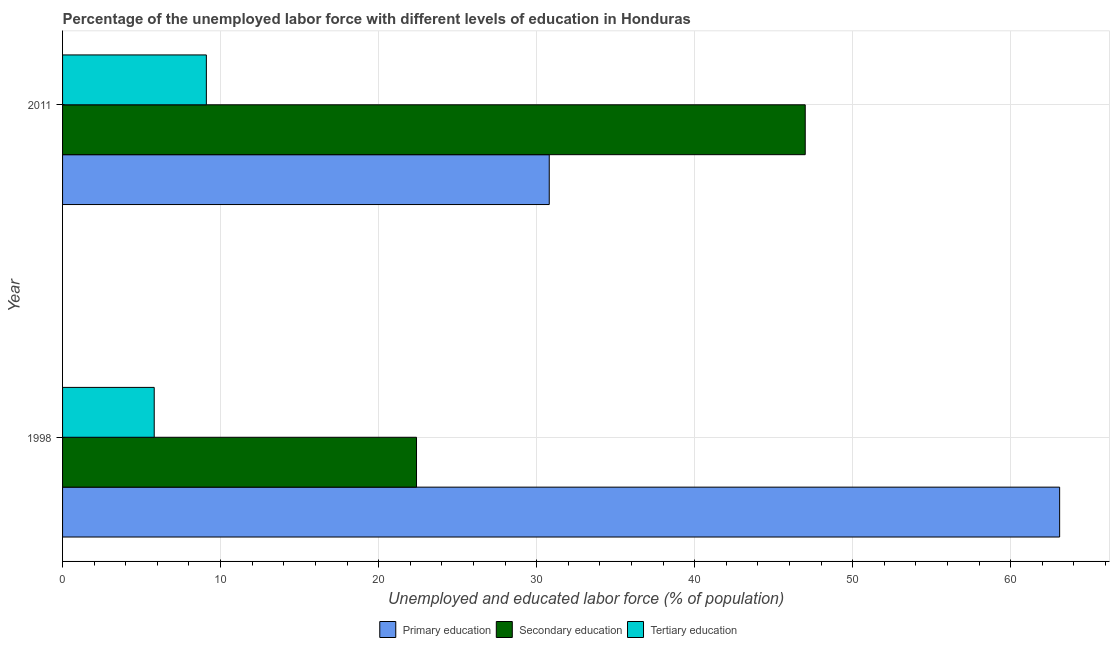How many different coloured bars are there?
Keep it short and to the point. 3. Are the number of bars on each tick of the Y-axis equal?
Make the answer very short. Yes. How many bars are there on the 1st tick from the bottom?
Your answer should be compact. 3. What is the label of the 2nd group of bars from the top?
Your answer should be very brief. 1998. What is the percentage of labor force who received tertiary education in 1998?
Your answer should be compact. 5.8. Across all years, what is the maximum percentage of labor force who received primary education?
Your answer should be very brief. 63.1. Across all years, what is the minimum percentage of labor force who received secondary education?
Your response must be concise. 22.4. What is the total percentage of labor force who received tertiary education in the graph?
Provide a short and direct response. 14.9. What is the difference between the percentage of labor force who received primary education in 1998 and that in 2011?
Ensure brevity in your answer.  32.3. What is the difference between the percentage of labor force who received tertiary education in 2011 and the percentage of labor force who received primary education in 1998?
Provide a succinct answer. -54. What is the average percentage of labor force who received secondary education per year?
Make the answer very short. 34.7. In the year 1998, what is the difference between the percentage of labor force who received secondary education and percentage of labor force who received primary education?
Provide a succinct answer. -40.7. What is the ratio of the percentage of labor force who received primary education in 1998 to that in 2011?
Make the answer very short. 2.05. What does the 2nd bar from the top in 2011 represents?
Give a very brief answer. Secondary education. What does the 3rd bar from the bottom in 2011 represents?
Your answer should be compact. Tertiary education. How many bars are there?
Make the answer very short. 6. What is the difference between two consecutive major ticks on the X-axis?
Provide a short and direct response. 10. What is the title of the graph?
Your response must be concise. Percentage of the unemployed labor force with different levels of education in Honduras. What is the label or title of the X-axis?
Give a very brief answer. Unemployed and educated labor force (% of population). What is the Unemployed and educated labor force (% of population) of Primary education in 1998?
Keep it short and to the point. 63.1. What is the Unemployed and educated labor force (% of population) of Secondary education in 1998?
Offer a terse response. 22.4. What is the Unemployed and educated labor force (% of population) in Tertiary education in 1998?
Offer a terse response. 5.8. What is the Unemployed and educated labor force (% of population) of Primary education in 2011?
Your response must be concise. 30.8. What is the Unemployed and educated labor force (% of population) in Tertiary education in 2011?
Provide a short and direct response. 9.1. Across all years, what is the maximum Unemployed and educated labor force (% of population) of Primary education?
Provide a succinct answer. 63.1. Across all years, what is the maximum Unemployed and educated labor force (% of population) in Secondary education?
Provide a succinct answer. 47. Across all years, what is the maximum Unemployed and educated labor force (% of population) in Tertiary education?
Ensure brevity in your answer.  9.1. Across all years, what is the minimum Unemployed and educated labor force (% of population) in Primary education?
Your response must be concise. 30.8. Across all years, what is the minimum Unemployed and educated labor force (% of population) in Secondary education?
Provide a succinct answer. 22.4. Across all years, what is the minimum Unemployed and educated labor force (% of population) in Tertiary education?
Offer a terse response. 5.8. What is the total Unemployed and educated labor force (% of population) in Primary education in the graph?
Your response must be concise. 93.9. What is the total Unemployed and educated labor force (% of population) of Secondary education in the graph?
Offer a very short reply. 69.4. What is the difference between the Unemployed and educated labor force (% of population) of Primary education in 1998 and that in 2011?
Provide a succinct answer. 32.3. What is the difference between the Unemployed and educated labor force (% of population) of Secondary education in 1998 and that in 2011?
Offer a very short reply. -24.6. What is the average Unemployed and educated labor force (% of population) of Primary education per year?
Your answer should be compact. 46.95. What is the average Unemployed and educated labor force (% of population) in Secondary education per year?
Offer a terse response. 34.7. What is the average Unemployed and educated labor force (% of population) in Tertiary education per year?
Give a very brief answer. 7.45. In the year 1998, what is the difference between the Unemployed and educated labor force (% of population) of Primary education and Unemployed and educated labor force (% of population) of Secondary education?
Offer a terse response. 40.7. In the year 1998, what is the difference between the Unemployed and educated labor force (% of population) of Primary education and Unemployed and educated labor force (% of population) of Tertiary education?
Provide a succinct answer. 57.3. In the year 1998, what is the difference between the Unemployed and educated labor force (% of population) of Secondary education and Unemployed and educated labor force (% of population) of Tertiary education?
Give a very brief answer. 16.6. In the year 2011, what is the difference between the Unemployed and educated labor force (% of population) of Primary education and Unemployed and educated labor force (% of population) of Secondary education?
Your response must be concise. -16.2. In the year 2011, what is the difference between the Unemployed and educated labor force (% of population) in Primary education and Unemployed and educated labor force (% of population) in Tertiary education?
Your answer should be very brief. 21.7. In the year 2011, what is the difference between the Unemployed and educated labor force (% of population) of Secondary education and Unemployed and educated labor force (% of population) of Tertiary education?
Your answer should be very brief. 37.9. What is the ratio of the Unemployed and educated labor force (% of population) in Primary education in 1998 to that in 2011?
Your answer should be compact. 2.05. What is the ratio of the Unemployed and educated labor force (% of population) of Secondary education in 1998 to that in 2011?
Provide a short and direct response. 0.48. What is the ratio of the Unemployed and educated labor force (% of population) of Tertiary education in 1998 to that in 2011?
Keep it short and to the point. 0.64. What is the difference between the highest and the second highest Unemployed and educated labor force (% of population) in Primary education?
Provide a succinct answer. 32.3. What is the difference between the highest and the second highest Unemployed and educated labor force (% of population) in Secondary education?
Ensure brevity in your answer.  24.6. What is the difference between the highest and the lowest Unemployed and educated labor force (% of population) of Primary education?
Give a very brief answer. 32.3. What is the difference between the highest and the lowest Unemployed and educated labor force (% of population) of Secondary education?
Offer a terse response. 24.6. What is the difference between the highest and the lowest Unemployed and educated labor force (% of population) in Tertiary education?
Keep it short and to the point. 3.3. 